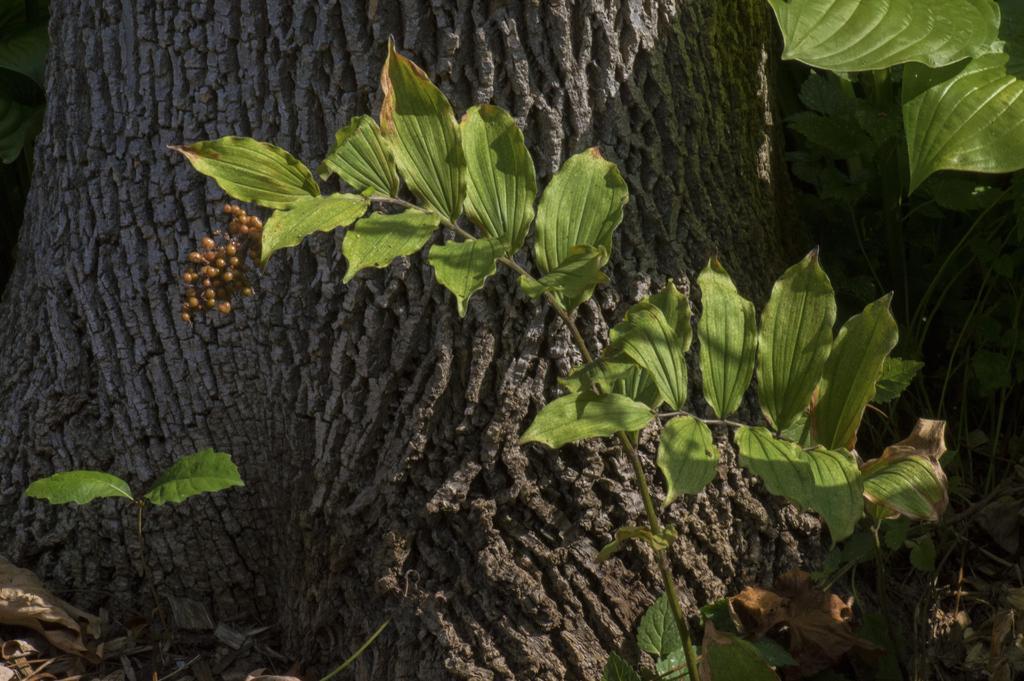Describe this image in one or two sentences. This is the picture of a plant to which there are some things and behind there is a tree trunk. 